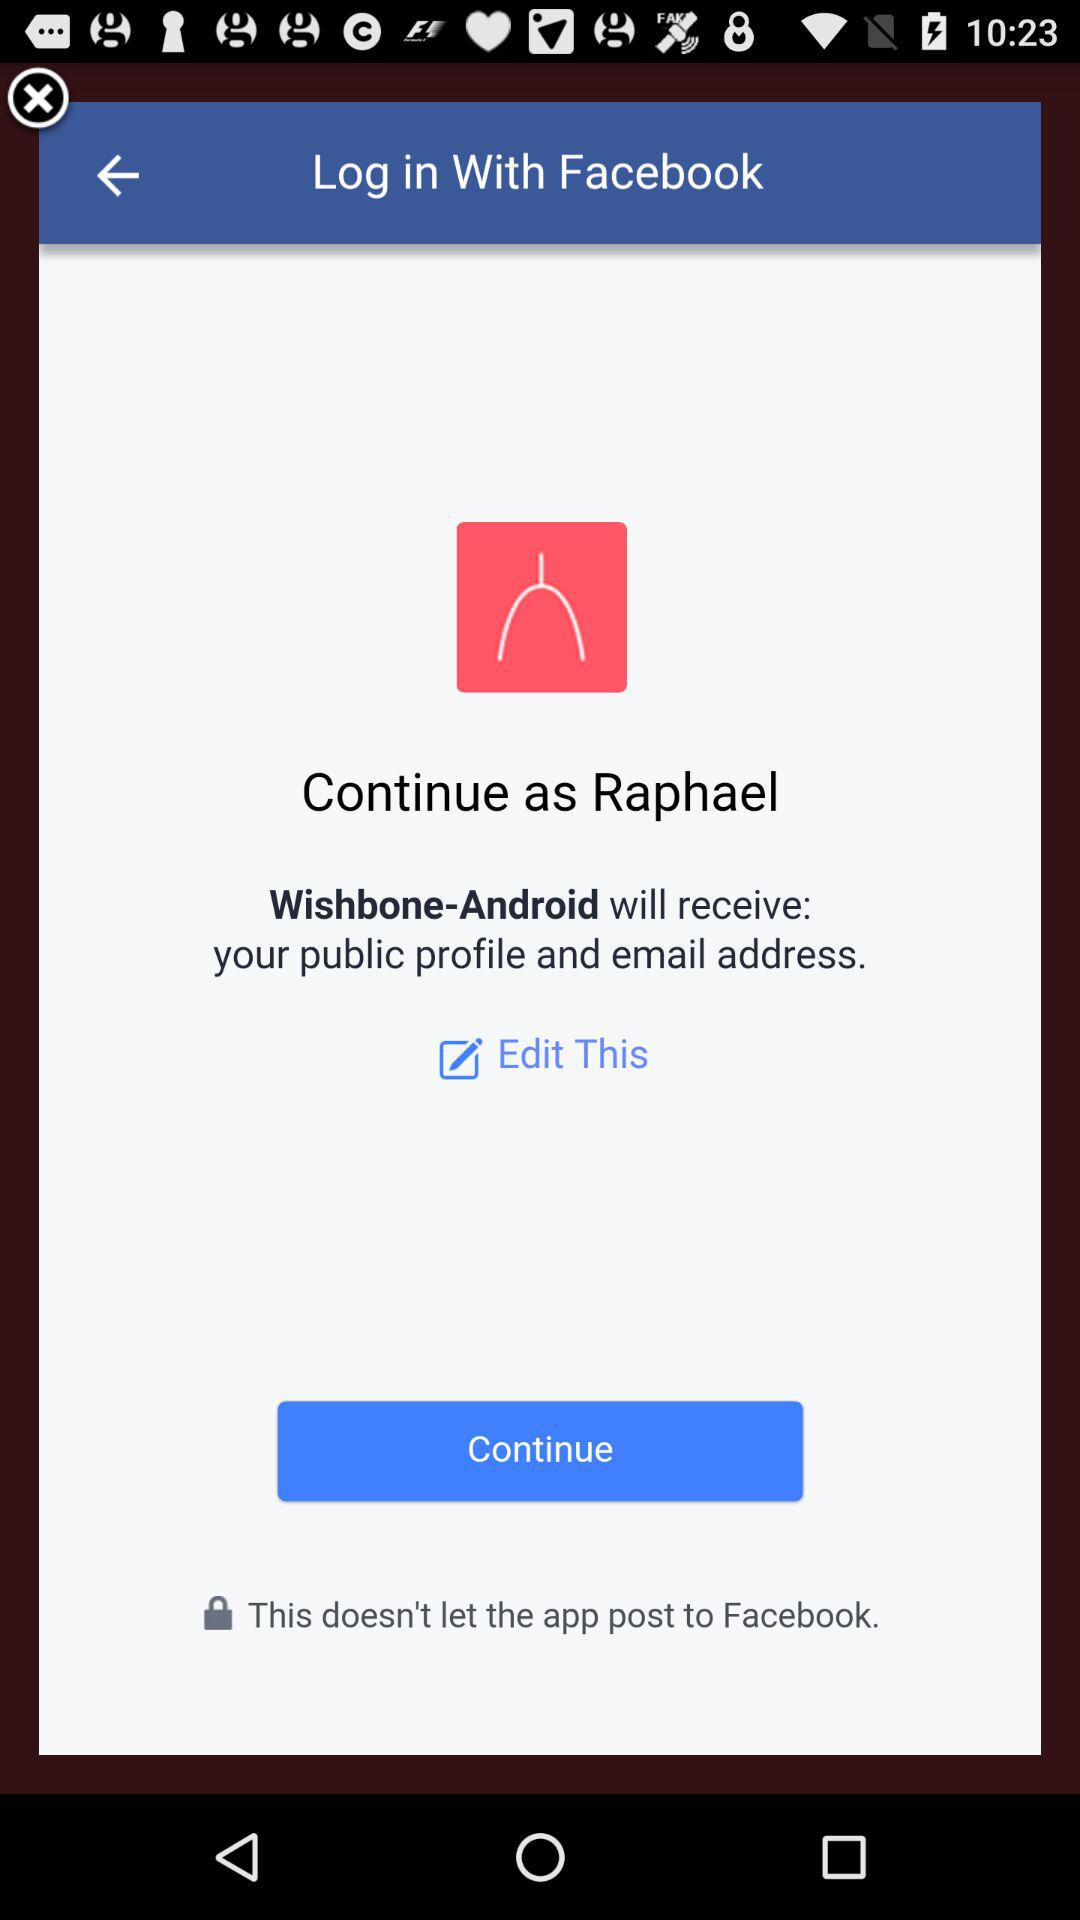What application is asking for permission? The application asking for permission is "Wishbone-Android". 